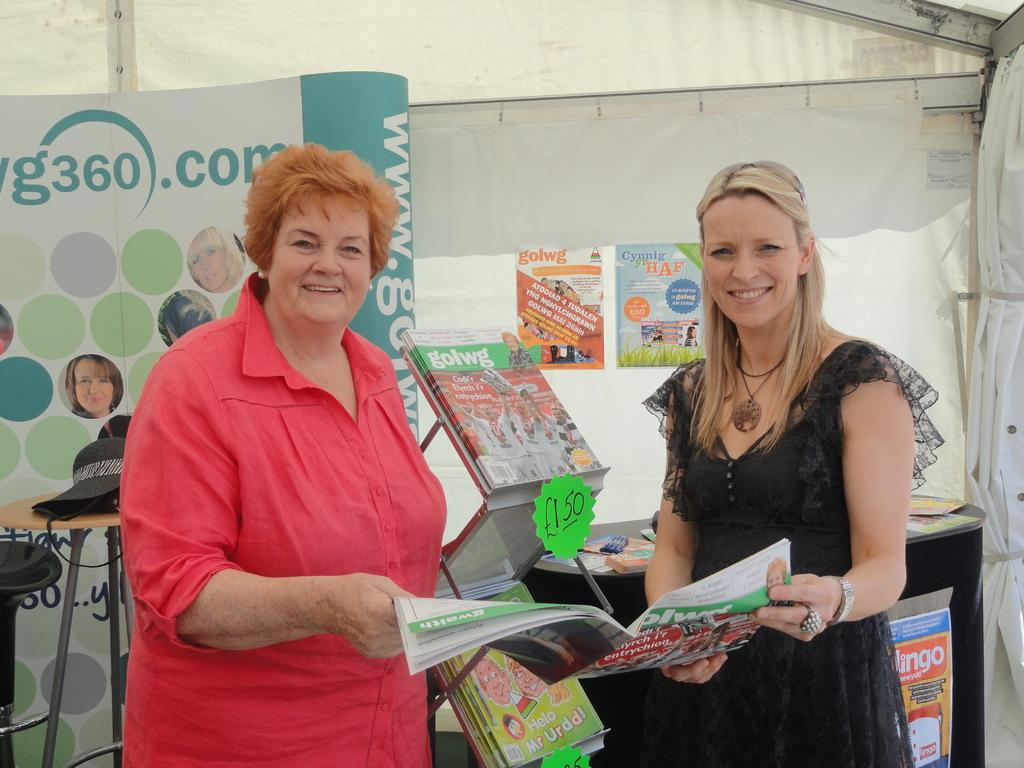How many people are in the image? There are two women in the image. What are the women holding in the image? The women are holding a book. Can you describe the object on the table in the image? Unfortunately, the facts provided do not mention any object on a table. How many eggs are on the desk in the image? There is no desk or eggs present in the image. 